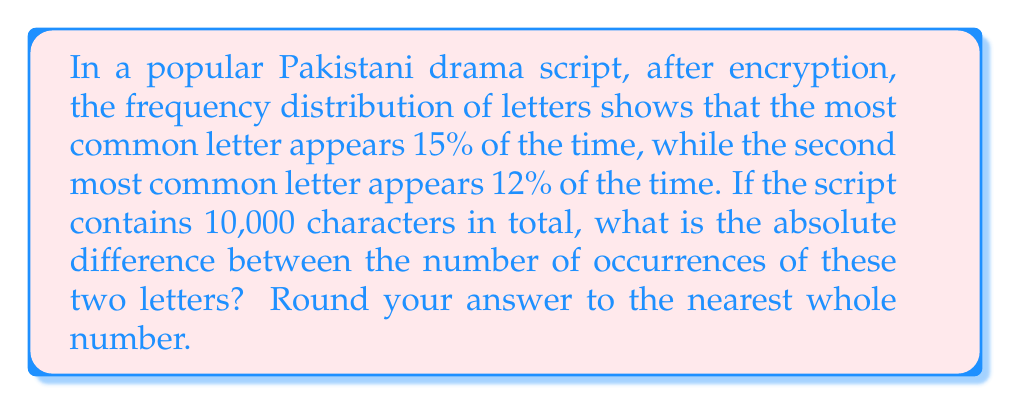Help me with this question. Let's approach this step-by-step:

1) First, let's calculate the number of occurrences for each letter:

   Most common letter:
   $$ 15\% \text{ of } 10,000 = 0.15 \times 10,000 = 1,500 \text{ occurrences} $$

   Second most common letter:
   $$ 12\% \text{ of } 10,000 = 0.12 \times 10,000 = 1,200 \text{ occurrences} $$

2) Now, we need to find the absolute difference between these two numbers:

   $$ |1,500 - 1,200| = 300 $$

3) The question asks for the answer rounded to the nearest whole number, but 300 is already a whole number, so no rounding is necessary.
Answer: 300 